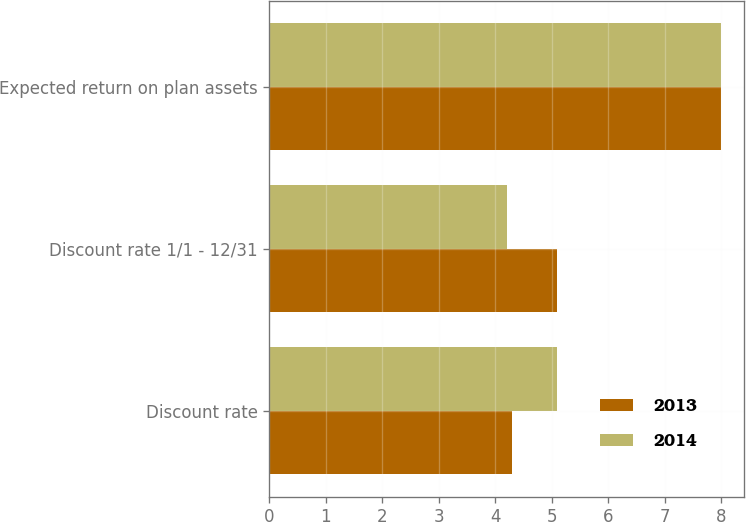<chart> <loc_0><loc_0><loc_500><loc_500><stacked_bar_chart><ecel><fcel>Discount rate<fcel>Discount rate 1/1 - 12/31<fcel>Expected return on plan assets<nl><fcel>2013<fcel>4.3<fcel>5.1<fcel>8<nl><fcel>2014<fcel>5.1<fcel>4.2<fcel>8<nl></chart> 